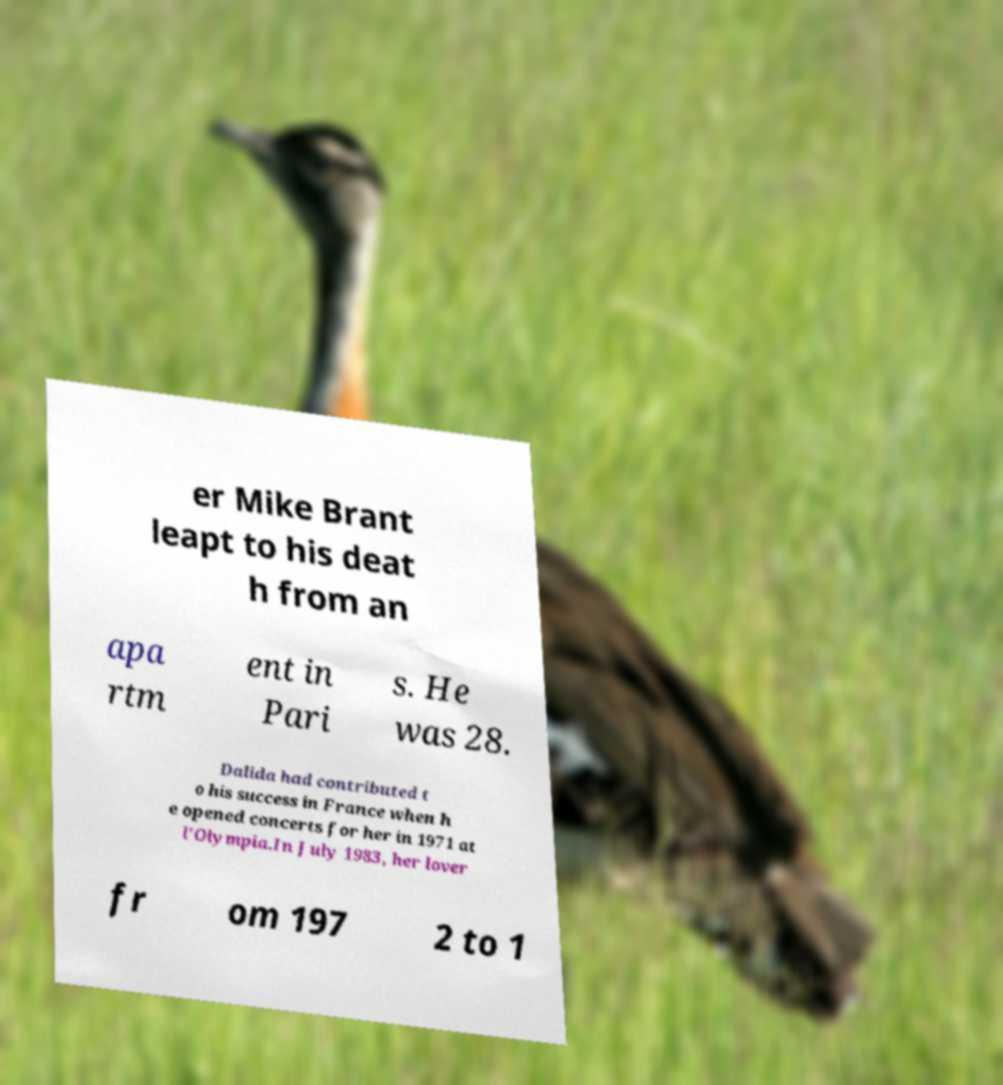Can you accurately transcribe the text from the provided image for me? er Mike Brant leapt to his deat h from an apa rtm ent in Pari s. He was 28. Dalida had contributed t o his success in France when h e opened concerts for her in 1971 at l'Olympia.In July 1983, her lover fr om 197 2 to 1 